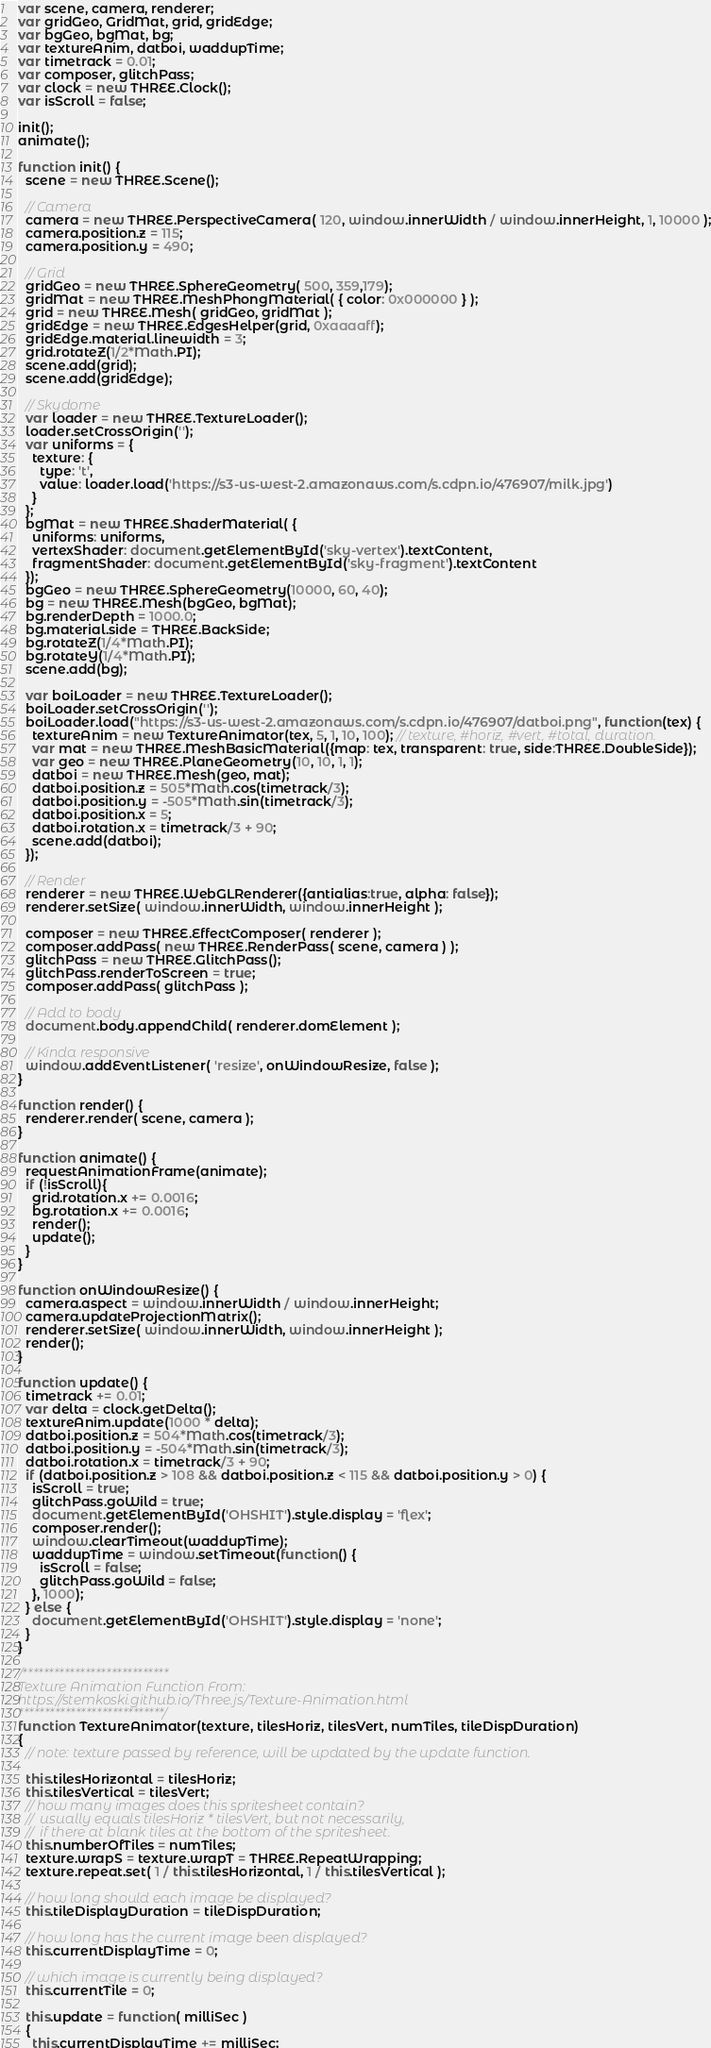Convert code to text. <code><loc_0><loc_0><loc_500><loc_500><_JavaScript_>var scene, camera, renderer;
var gridGeo, GridMat, grid, gridEdge;
var bgGeo, bgMat, bg;
var textureAnim, datboi, waddupTime;
var timetrack = 0.01;
var composer, glitchPass;
var clock = new THREE.Clock();
var isScroll = false;

init();
animate();

function init() {
  scene = new THREE.Scene();

  // Camera
  camera = new THREE.PerspectiveCamera( 120, window.innerWidth / window.innerHeight, 1, 10000 );
  camera.position.z = 115;
  camera.position.y = 490;

  // Grid
  gridGeo = new THREE.SphereGeometry( 500, 359,179);
  gridMat = new THREE.MeshPhongMaterial( { color: 0x000000 } );
  grid = new THREE.Mesh( gridGeo, gridMat );
  gridEdge = new THREE.EdgesHelper(grid, 0xaaaaff);
  gridEdge.material.linewidth = 3;
  grid.rotateZ(1/2*Math.PI);
  scene.add(grid);
  scene.add(gridEdge);

  // Skydome
  var loader = new THREE.TextureLoader();
  loader.setCrossOrigin('');
  var uniforms = {  
    texture: {
      type: 't',
      value: loader.load('https://s3-us-west-2.amazonaws.com/s.cdpn.io/476907/milk.jpg')
    }
  };
  bgMat = new THREE.ShaderMaterial( {  
    uniforms: uniforms,
    vertexShader: document.getElementById('sky-vertex').textContent,
    fragmentShader: document.getElementById('sky-fragment').textContent
  });
  bgGeo = new THREE.SphereGeometry(10000, 60, 40);
  bg = new THREE.Mesh(bgGeo, bgMat);
  bg.renderDepth = 1000.0;  
  bg.material.side = THREE.BackSide;
  bg.rotateZ(1/4*Math.PI);
  bg.rotateY(1/4*Math.PI);
  scene.add(bg);

  var boiLoader = new THREE.TextureLoader();
  boiLoader.setCrossOrigin('');
  boiLoader.load("https://s3-us-west-2.amazonaws.com/s.cdpn.io/476907/datboi.png", function(tex) {
    textureAnim = new TextureAnimator(tex, 5, 1, 10, 100); // texture, #horiz, #vert, #total, duration.
    var mat = new THREE.MeshBasicMaterial({map: tex, transparent: true, side:THREE.DoubleSide});
    var geo = new THREE.PlaneGeometry(10, 10, 1, 1);
    datboi = new THREE.Mesh(geo, mat);
    datboi.position.z = 505*Math.cos(timetrack/3);
    datboi.position.y = -505*Math.sin(timetrack/3);
    datboi.position.x = 5;
    datboi.rotation.x = timetrack/3 + 90;
    scene.add(datboi);
  });
  
  // Render
  renderer = new THREE.WebGLRenderer({antialias:true, alpha: false});
  renderer.setSize( window.innerWidth, window.innerHeight );
  
  composer = new THREE.EffectComposer( renderer );
  composer.addPass( new THREE.RenderPass( scene, camera ) );
  glitchPass = new THREE.GlitchPass();
  glitchPass.renderToScreen = true;
  composer.addPass( glitchPass );

  // Add to body
  document.body.appendChild( renderer.domElement );

  // Kinda responsive
  window.addEventListener( 'resize', onWindowResize, false );
}

function render() {
  renderer.render( scene, camera );
}

function animate() {
  requestAnimationFrame(animate);
  if (!isScroll){
    grid.rotation.x += 0.0016;
    bg.rotation.x += 0.0016;
    render();
    update();
  }
}

function onWindowResize() {
  camera.aspect = window.innerWidth / window.innerHeight;
  camera.updateProjectionMatrix();
  renderer.setSize( window.innerWidth, window.innerHeight );
  render();
}

function update() {
  timetrack += 0.01;
  var delta = clock.getDelta(); 
  textureAnim.update(1000 * delta);
  datboi.position.z = 504*Math.cos(timetrack/3);
  datboi.position.y = -504*Math.sin(timetrack/3);
  datboi.rotation.x = timetrack/3 + 90;
  if (datboi.position.z > 108 && datboi.position.z < 115 && datboi.position.y > 0) {
    isScroll = true;
    glitchPass.goWild = true;
    document.getElementById('OHSHIT').style.display = 'flex';
    composer.render();
    window.clearTimeout(waddupTime);
    waddupTime = window.setTimeout(function() {
      isScroll = false;
      glitchPass.goWild = false;
    }, 1000);
  } else {
    document.getElementById('OHSHIT').style.display = 'none';
  }
}

/****************************
Texture Animation Function From:
https://stemkoski.github.io/Three.js/Texture-Animation.html
****************************/
function TextureAnimator(texture, tilesHoriz, tilesVert, numTiles, tileDispDuration) 
{	
  // note: texture passed by reference, will be updated by the update function.

  this.tilesHorizontal = tilesHoriz;
  this.tilesVertical = tilesVert;
  // how many images does this spritesheet contain?
  //  usually equals tilesHoriz * tilesVert, but not necessarily,
  //  if there at blank tiles at the bottom of the spritesheet. 
  this.numberOfTiles = numTiles;
  texture.wrapS = texture.wrapT = THREE.RepeatWrapping; 
  texture.repeat.set( 1 / this.tilesHorizontal, 1 / this.tilesVertical );

  // how long should each image be displayed?
  this.tileDisplayDuration = tileDispDuration;

  // how long has the current image been displayed?
  this.currentDisplayTime = 0;

  // which image is currently being displayed?
  this.currentTile = 0;

  this.update = function( milliSec )
  {
    this.currentDisplayTime += milliSec;</code> 